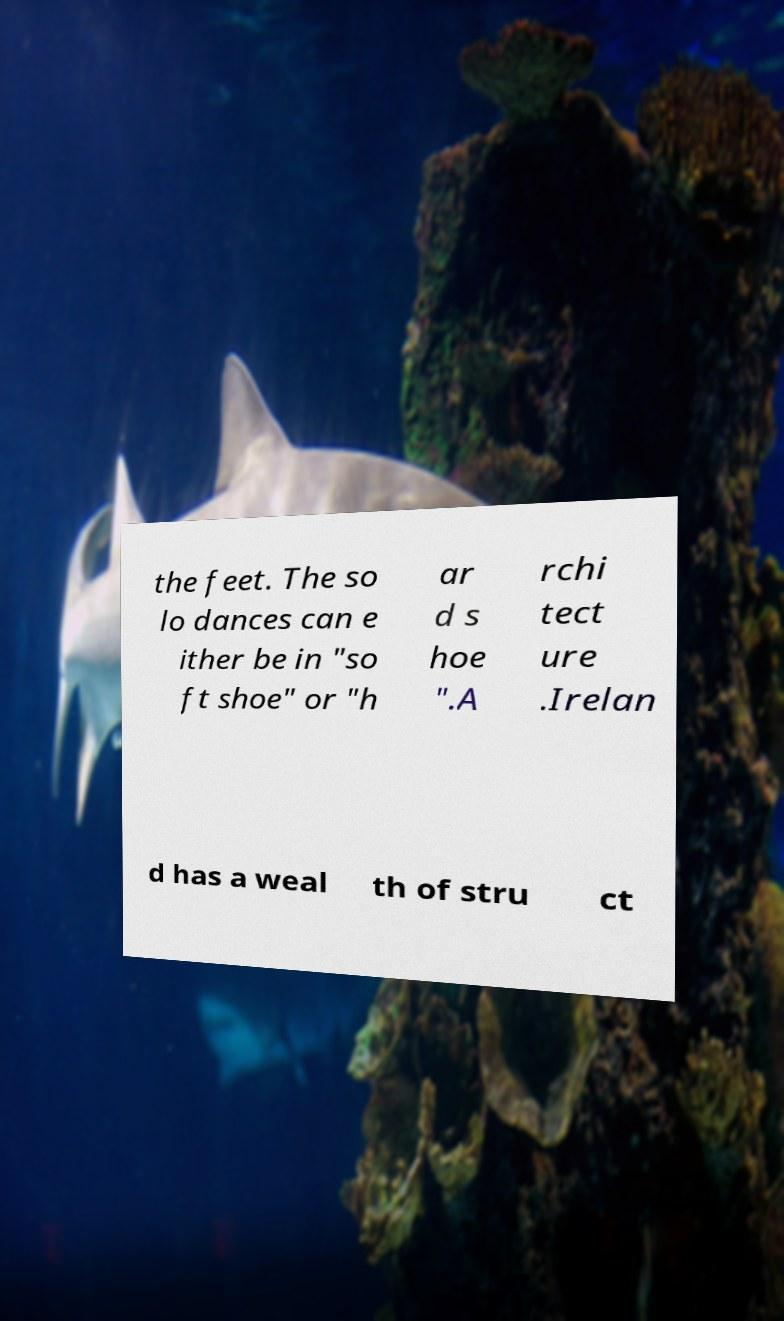I need the written content from this picture converted into text. Can you do that? the feet. The so lo dances can e ither be in "so ft shoe" or "h ar d s hoe ".A rchi tect ure .Irelan d has a weal th of stru ct 